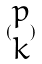Convert formula to latex. <formula><loc_0><loc_0><loc_500><loc_500>( \begin{matrix} p \\ k \end{matrix} )</formula> 